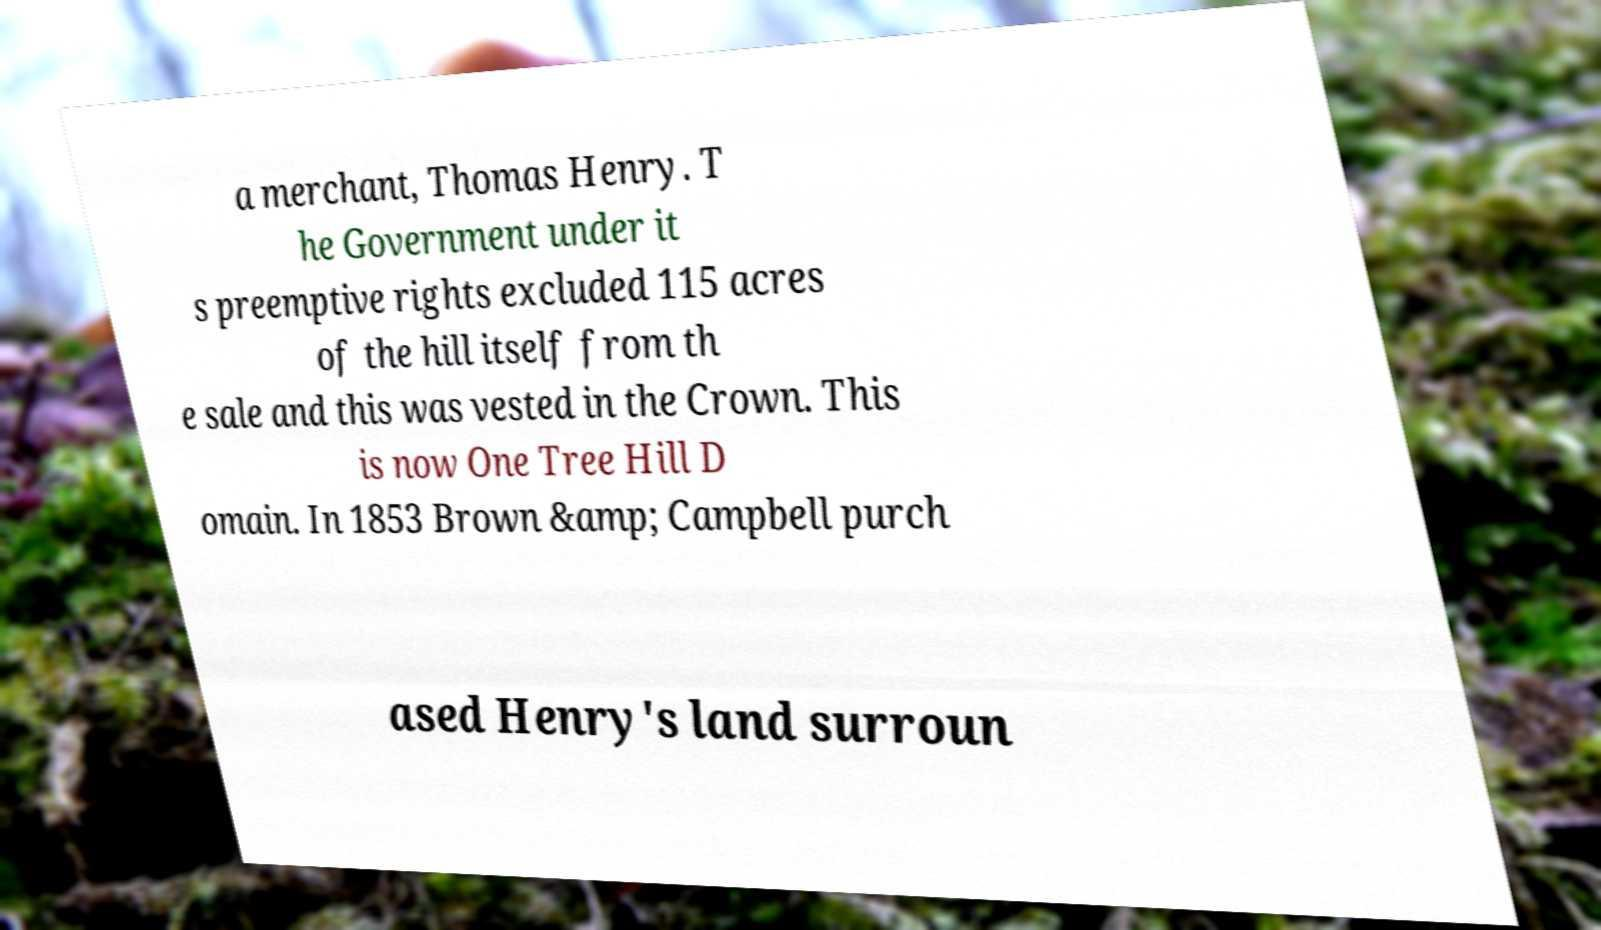I need the written content from this picture converted into text. Can you do that? a merchant, Thomas Henry. T he Government under it s preemptive rights excluded 115 acres of the hill itself from th e sale and this was vested in the Crown. This is now One Tree Hill D omain. In 1853 Brown &amp; Campbell purch ased Henry's land surroun 